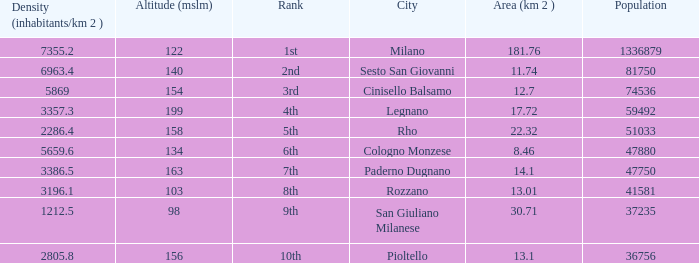Which Altitude (mslm) is the highest one that has a City of legnano, and a Population larger than 59492? None. 